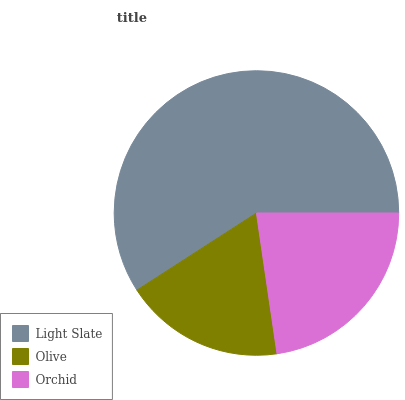Is Olive the minimum?
Answer yes or no. Yes. Is Light Slate the maximum?
Answer yes or no. Yes. Is Orchid the minimum?
Answer yes or no. No. Is Orchid the maximum?
Answer yes or no. No. Is Orchid greater than Olive?
Answer yes or no. Yes. Is Olive less than Orchid?
Answer yes or no. Yes. Is Olive greater than Orchid?
Answer yes or no. No. Is Orchid less than Olive?
Answer yes or no. No. Is Orchid the high median?
Answer yes or no. Yes. Is Orchid the low median?
Answer yes or no. Yes. Is Light Slate the high median?
Answer yes or no. No. Is Olive the low median?
Answer yes or no. No. 